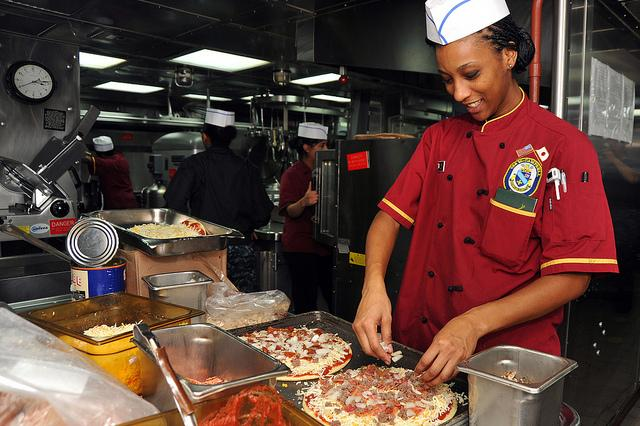What period of the day is it in the image? Please explain your reasoning. afternoon. The man is making pizza. 